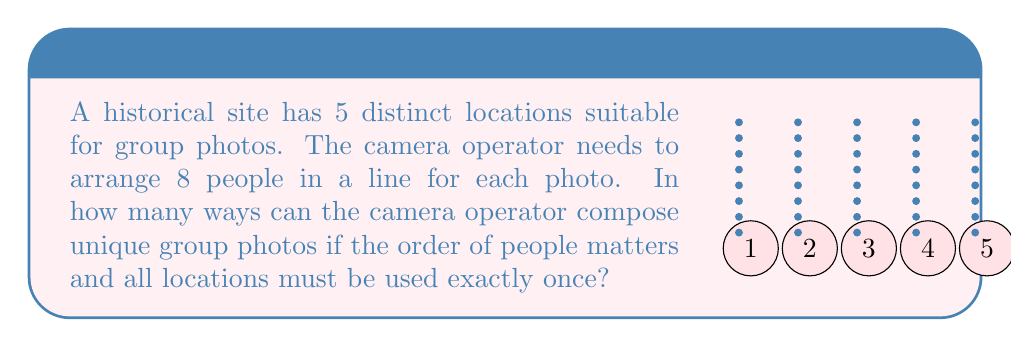Can you answer this question? Let's approach this step-by-step:

1) First, we need to consider the number of ways to arrange 8 people in a line. This is a straightforward permutation:
   
   $$P(8,8) = 8! = 40,320$$

2) Now, we need to do this for each of the 5 locations. Since the order of locations matters (as we're capturing different historical spots), we need to multiply our result by 5!:

   $$40,320 \cdot 5! = 40,320 \cdot 120 = 4,838,400$$

3) However, this calculation assumes that the same arrangement of people can be used at each location. To ensure unique compositions, we need to use a different arrangement for each location.

4) This scenario can be modeled as a derangement problem. We need to find the number of ways to arrange 5 items (our locations) such that no item is in its original position.

5) The number of derangements for n items is given by the formula:

   $$!n = n! \sum_{k=0}^n \frac{(-1)^k}{k!}$$

6) For n = 5:

   $$!5 = 5! \left(\frac{1}{0!} - \frac{1}{1!} + \frac{1}{2!} - \frac{1}{3!} + \frac{1}{4!} - \frac{1}{5!}\right)$$

   $$= 120 \left(1 - 1 + \frac{1}{2} - \frac{1}{6} + \frac{1}{24} - \frac{1}{120}\right) = 44$$

7) Therefore, the total number of unique compositions is:

   $$44 \cdot 40,320 = 1,774,080$$
Answer: 1,774,080 